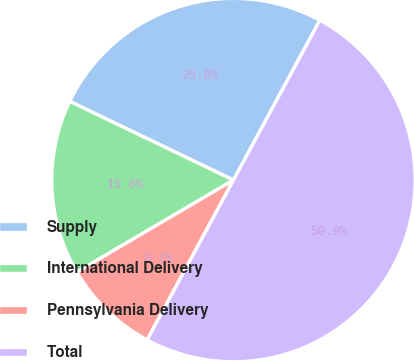Convert chart. <chart><loc_0><loc_0><loc_500><loc_500><pie_chart><fcel>Supply<fcel>International Delivery<fcel>Pennsylvania Delivery<fcel>Total<nl><fcel>25.75%<fcel>15.59%<fcel>8.66%<fcel>50.0%<nl></chart> 